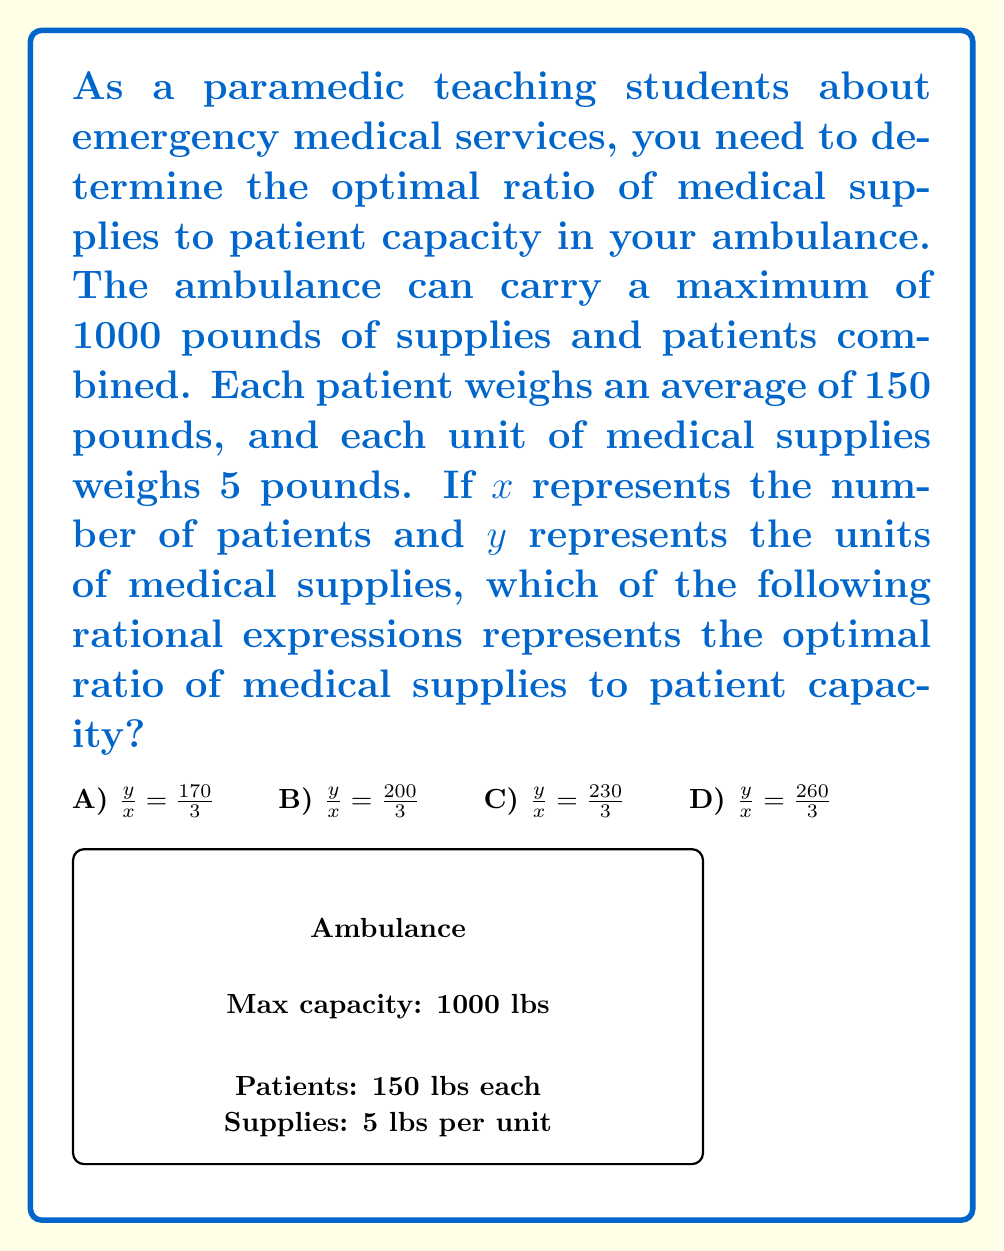Provide a solution to this math problem. Let's approach this step-by-step:

1) We know that the total weight of patients and supplies must not exceed 1000 pounds:
   
   $$150x + 5y \leq 1000$$

2) To find the optimal ratio, we want to maximize both x and y. This occurs when the equation is an equality:
   
   $$150x + 5y = 1000$$

3) Solve this equation for y:
   
   $$5y = 1000 - 150x$$
   $$y = 200 - 30x$$

4) Now, we want to find the ratio $\frac{y}{x}$:
   
   $$\frac{y}{x} = \frac{200 - 30x}{x}$$

5) Simplify this ratio:
   
   $$\frac{y}{x} = \frac{200}{x} - 30$$

6) To find the optimal ratio, we need to determine the average value of this expression. The maximum number of patients (x) the ambulance can carry is when y = 0:
   
   $$150x = 1000$$
   $$x = \frac{1000}{150} \approx 6.67$$

7) The minimum number of patients is 1. So, x ranges from 1 to 6.67.

8) Calculate the ratio for x = 1 and x = 6.67:
   
   For x = 1: $\frac{y}{x} = 200 - 30 = 170$
   For x = 6.67: $\frac{y}{x} = \frac{200}{6.67} - 30 \approx 0$

9) The average of these values is:
   
   $$\frac{170 + 0}{2} = 85$$

10) Multiply by 2 to get a whole number ratio:
    
    $$85 * 2 = 170$$

Therefore, the optimal ratio of medical supplies to patient capacity is 170:3.
Answer: $\frac{y}{x} = \frac{170}{3}$ 